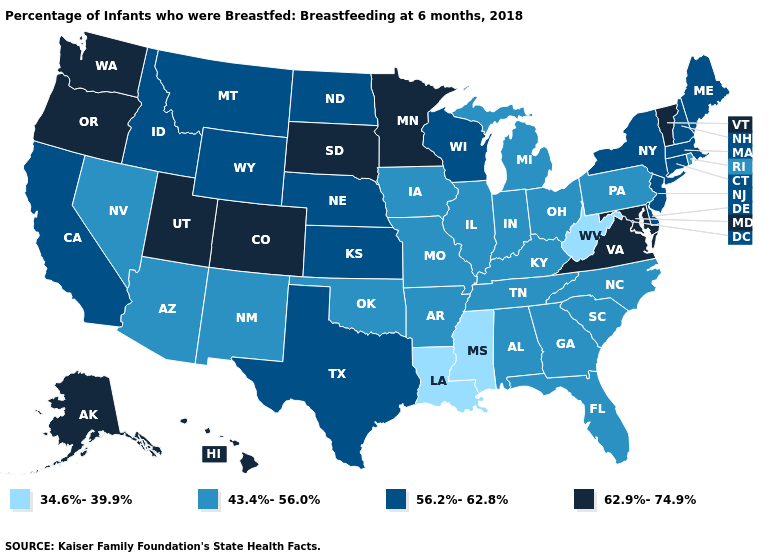Among the states that border Pennsylvania , which have the highest value?
Be succinct. Maryland. Name the states that have a value in the range 56.2%-62.8%?
Short answer required. California, Connecticut, Delaware, Idaho, Kansas, Maine, Massachusetts, Montana, Nebraska, New Hampshire, New Jersey, New York, North Dakota, Texas, Wisconsin, Wyoming. Does Mississippi have the highest value in the South?
Keep it brief. No. Does the map have missing data?
Concise answer only. No. Name the states that have a value in the range 62.9%-74.9%?
Write a very short answer. Alaska, Colorado, Hawaii, Maryland, Minnesota, Oregon, South Dakota, Utah, Vermont, Virginia, Washington. What is the value of New Hampshire?
Concise answer only. 56.2%-62.8%. What is the highest value in the Northeast ?
Give a very brief answer. 62.9%-74.9%. What is the value of New Jersey?
Quick response, please. 56.2%-62.8%. What is the lowest value in the USA?
Concise answer only. 34.6%-39.9%. Name the states that have a value in the range 62.9%-74.9%?
Short answer required. Alaska, Colorado, Hawaii, Maryland, Minnesota, Oregon, South Dakota, Utah, Vermont, Virginia, Washington. Does the first symbol in the legend represent the smallest category?
Write a very short answer. Yes. Name the states that have a value in the range 62.9%-74.9%?
Keep it brief. Alaska, Colorado, Hawaii, Maryland, Minnesota, Oregon, South Dakota, Utah, Vermont, Virginia, Washington. What is the value of Texas?
Quick response, please. 56.2%-62.8%. Is the legend a continuous bar?
Be succinct. No. Does Pennsylvania have the highest value in the Northeast?
Write a very short answer. No. 